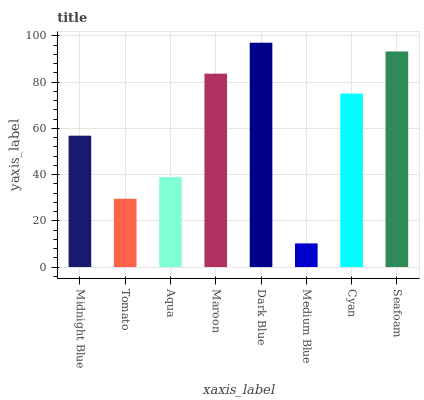Is Medium Blue the minimum?
Answer yes or no. Yes. Is Dark Blue the maximum?
Answer yes or no. Yes. Is Tomato the minimum?
Answer yes or no. No. Is Tomato the maximum?
Answer yes or no. No. Is Midnight Blue greater than Tomato?
Answer yes or no. Yes. Is Tomato less than Midnight Blue?
Answer yes or no. Yes. Is Tomato greater than Midnight Blue?
Answer yes or no. No. Is Midnight Blue less than Tomato?
Answer yes or no. No. Is Cyan the high median?
Answer yes or no. Yes. Is Midnight Blue the low median?
Answer yes or no. Yes. Is Midnight Blue the high median?
Answer yes or no. No. Is Seafoam the low median?
Answer yes or no. No. 